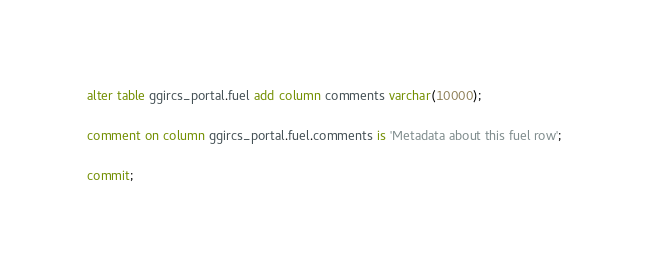Convert code to text. <code><loc_0><loc_0><loc_500><loc_500><_SQL_>alter table ggircs_portal.fuel add column comments varchar(10000);

comment on column ggircs_portal.fuel.comments is 'Metadata about this fuel row';

commit;
</code> 